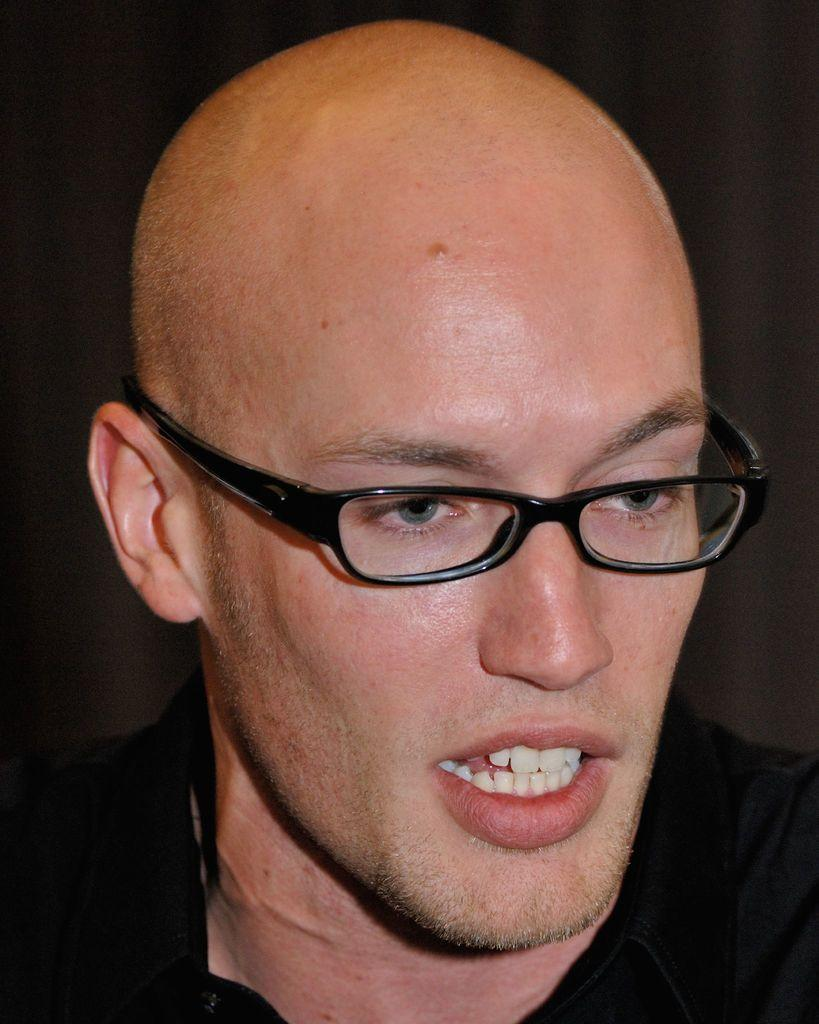Who is present in the image? There is a man in the image. What is the man wearing in the image? The man is wearing specs in the image. What can be observed about the background of the image? The background of the image is dark. Can you see any ants interacting with the man in the image? There are no ants present in the image. Is the man in the image sharing a kiss with someone? There is no indication of a kiss or any other interaction with another person in the image. 